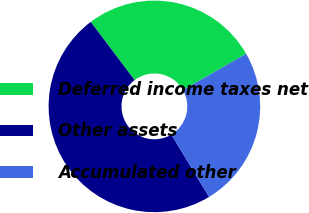Convert chart to OTSL. <chart><loc_0><loc_0><loc_500><loc_500><pie_chart><fcel>Deferred income taxes net<fcel>Other assets<fcel>Accumulated other<nl><fcel>27.0%<fcel>48.37%<fcel>24.63%<nl></chart> 